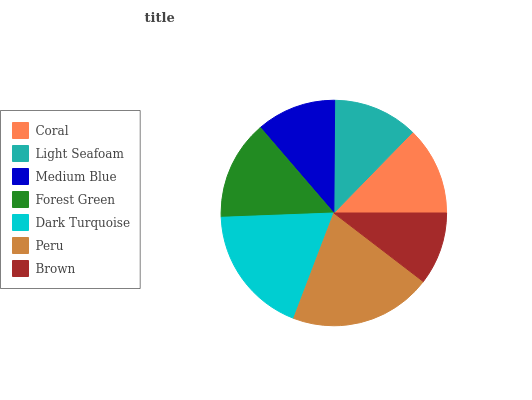Is Brown the minimum?
Answer yes or no. Yes. Is Peru the maximum?
Answer yes or no. Yes. Is Light Seafoam the minimum?
Answer yes or no. No. Is Light Seafoam the maximum?
Answer yes or no. No. Is Coral greater than Light Seafoam?
Answer yes or no. Yes. Is Light Seafoam less than Coral?
Answer yes or no. Yes. Is Light Seafoam greater than Coral?
Answer yes or no. No. Is Coral less than Light Seafoam?
Answer yes or no. No. Is Coral the high median?
Answer yes or no. Yes. Is Coral the low median?
Answer yes or no. Yes. Is Forest Green the high median?
Answer yes or no. No. Is Medium Blue the low median?
Answer yes or no. No. 